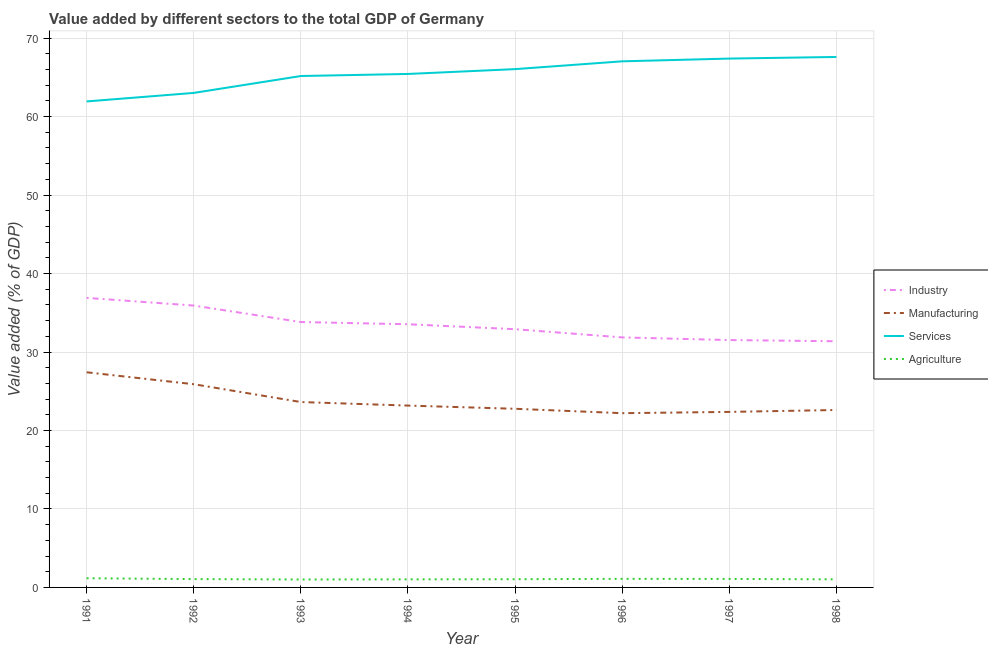Does the line corresponding to value added by manufacturing sector intersect with the line corresponding to value added by agricultural sector?
Ensure brevity in your answer.  No. Is the number of lines equal to the number of legend labels?
Provide a succinct answer. Yes. What is the value added by industrial sector in 1994?
Give a very brief answer. 33.54. Across all years, what is the maximum value added by services sector?
Keep it short and to the point. 67.6. Across all years, what is the minimum value added by industrial sector?
Your response must be concise. 31.37. What is the total value added by manufacturing sector in the graph?
Your response must be concise. 190.06. What is the difference between the value added by agricultural sector in 1994 and that in 1996?
Provide a short and direct response. -0.07. What is the difference between the value added by agricultural sector in 1993 and the value added by manufacturing sector in 1997?
Make the answer very short. -21.36. What is the average value added by manufacturing sector per year?
Make the answer very short. 23.76. In the year 1994, what is the difference between the value added by manufacturing sector and value added by services sector?
Your answer should be very brief. -42.26. What is the ratio of the value added by agricultural sector in 1991 to that in 1996?
Provide a short and direct response. 1.07. Is the value added by agricultural sector in 1992 less than that in 1994?
Your answer should be very brief. No. What is the difference between the highest and the second highest value added by services sector?
Give a very brief answer. 0.21. What is the difference between the highest and the lowest value added by industrial sector?
Your response must be concise. 5.53. In how many years, is the value added by manufacturing sector greater than the average value added by manufacturing sector taken over all years?
Your answer should be very brief. 2. Is the sum of the value added by industrial sector in 1993 and 1996 greater than the maximum value added by agricultural sector across all years?
Your answer should be compact. Yes. Is it the case that in every year, the sum of the value added by manufacturing sector and value added by agricultural sector is greater than the sum of value added by industrial sector and value added by services sector?
Give a very brief answer. Yes. Is it the case that in every year, the sum of the value added by industrial sector and value added by manufacturing sector is greater than the value added by services sector?
Your response must be concise. No. Is the value added by industrial sector strictly greater than the value added by manufacturing sector over the years?
Keep it short and to the point. Yes. How many years are there in the graph?
Keep it short and to the point. 8. What is the difference between two consecutive major ticks on the Y-axis?
Make the answer very short. 10. Are the values on the major ticks of Y-axis written in scientific E-notation?
Offer a very short reply. No. Does the graph contain grids?
Your response must be concise. Yes. How many legend labels are there?
Your response must be concise. 4. What is the title of the graph?
Ensure brevity in your answer.  Value added by different sectors to the total GDP of Germany. What is the label or title of the Y-axis?
Provide a short and direct response. Value added (% of GDP). What is the Value added (% of GDP) of Industry in 1991?
Offer a very short reply. 36.9. What is the Value added (% of GDP) in Manufacturing in 1991?
Your response must be concise. 27.42. What is the Value added (% of GDP) in Services in 1991?
Give a very brief answer. 61.93. What is the Value added (% of GDP) in Agriculture in 1991?
Offer a terse response. 1.17. What is the Value added (% of GDP) in Industry in 1992?
Offer a terse response. 35.92. What is the Value added (% of GDP) of Manufacturing in 1992?
Keep it short and to the point. 25.9. What is the Value added (% of GDP) in Services in 1992?
Provide a succinct answer. 63.02. What is the Value added (% of GDP) in Agriculture in 1992?
Your answer should be compact. 1.06. What is the Value added (% of GDP) of Industry in 1993?
Provide a succinct answer. 33.82. What is the Value added (% of GDP) of Manufacturing in 1993?
Ensure brevity in your answer.  23.63. What is the Value added (% of GDP) of Services in 1993?
Keep it short and to the point. 65.17. What is the Value added (% of GDP) of Agriculture in 1993?
Your answer should be very brief. 1.01. What is the Value added (% of GDP) of Industry in 1994?
Offer a terse response. 33.54. What is the Value added (% of GDP) of Manufacturing in 1994?
Provide a succinct answer. 23.17. What is the Value added (% of GDP) in Services in 1994?
Your response must be concise. 65.43. What is the Value added (% of GDP) of Agriculture in 1994?
Your answer should be compact. 1.03. What is the Value added (% of GDP) in Industry in 1995?
Your answer should be very brief. 32.91. What is the Value added (% of GDP) of Manufacturing in 1995?
Offer a very short reply. 22.77. What is the Value added (% of GDP) of Services in 1995?
Provide a short and direct response. 66.05. What is the Value added (% of GDP) in Agriculture in 1995?
Give a very brief answer. 1.04. What is the Value added (% of GDP) of Industry in 1996?
Give a very brief answer. 31.86. What is the Value added (% of GDP) in Manufacturing in 1996?
Ensure brevity in your answer.  22.21. What is the Value added (% of GDP) of Services in 1996?
Your answer should be very brief. 67.04. What is the Value added (% of GDP) in Agriculture in 1996?
Provide a short and direct response. 1.09. What is the Value added (% of GDP) of Industry in 1997?
Give a very brief answer. 31.52. What is the Value added (% of GDP) of Manufacturing in 1997?
Provide a succinct answer. 22.37. What is the Value added (% of GDP) of Services in 1997?
Keep it short and to the point. 67.39. What is the Value added (% of GDP) in Agriculture in 1997?
Ensure brevity in your answer.  1.08. What is the Value added (% of GDP) in Industry in 1998?
Give a very brief answer. 31.37. What is the Value added (% of GDP) in Manufacturing in 1998?
Give a very brief answer. 22.61. What is the Value added (% of GDP) in Services in 1998?
Offer a terse response. 67.6. What is the Value added (% of GDP) in Agriculture in 1998?
Your answer should be very brief. 1.03. Across all years, what is the maximum Value added (% of GDP) of Industry?
Provide a short and direct response. 36.9. Across all years, what is the maximum Value added (% of GDP) in Manufacturing?
Your answer should be compact. 27.42. Across all years, what is the maximum Value added (% of GDP) in Services?
Keep it short and to the point. 67.6. Across all years, what is the maximum Value added (% of GDP) of Agriculture?
Provide a short and direct response. 1.17. Across all years, what is the minimum Value added (% of GDP) of Industry?
Your answer should be very brief. 31.37. Across all years, what is the minimum Value added (% of GDP) of Manufacturing?
Provide a short and direct response. 22.21. Across all years, what is the minimum Value added (% of GDP) of Services?
Provide a succinct answer. 61.93. Across all years, what is the minimum Value added (% of GDP) in Agriculture?
Your answer should be compact. 1.01. What is the total Value added (% of GDP) in Industry in the graph?
Offer a very short reply. 267.84. What is the total Value added (% of GDP) of Manufacturing in the graph?
Keep it short and to the point. 190.06. What is the total Value added (% of GDP) of Services in the graph?
Provide a short and direct response. 523.64. What is the total Value added (% of GDP) in Agriculture in the graph?
Keep it short and to the point. 8.52. What is the difference between the Value added (% of GDP) in Industry in 1991 and that in 1992?
Provide a short and direct response. 0.98. What is the difference between the Value added (% of GDP) of Manufacturing in 1991 and that in 1992?
Offer a terse response. 1.52. What is the difference between the Value added (% of GDP) in Services in 1991 and that in 1992?
Offer a terse response. -1.09. What is the difference between the Value added (% of GDP) of Agriculture in 1991 and that in 1992?
Provide a succinct answer. 0.11. What is the difference between the Value added (% of GDP) in Industry in 1991 and that in 1993?
Give a very brief answer. 3.08. What is the difference between the Value added (% of GDP) in Manufacturing in 1991 and that in 1993?
Make the answer very short. 3.79. What is the difference between the Value added (% of GDP) of Services in 1991 and that in 1993?
Your answer should be compact. -3.24. What is the difference between the Value added (% of GDP) of Agriculture in 1991 and that in 1993?
Your answer should be compact. 0.16. What is the difference between the Value added (% of GDP) in Industry in 1991 and that in 1994?
Offer a terse response. 3.36. What is the difference between the Value added (% of GDP) of Manufacturing in 1991 and that in 1994?
Offer a terse response. 4.24. What is the difference between the Value added (% of GDP) in Services in 1991 and that in 1994?
Offer a terse response. -3.5. What is the difference between the Value added (% of GDP) in Agriculture in 1991 and that in 1994?
Provide a succinct answer. 0.14. What is the difference between the Value added (% of GDP) in Industry in 1991 and that in 1995?
Provide a succinct answer. 3.99. What is the difference between the Value added (% of GDP) of Manufacturing in 1991 and that in 1995?
Provide a succinct answer. 4.65. What is the difference between the Value added (% of GDP) of Services in 1991 and that in 1995?
Offer a terse response. -4.12. What is the difference between the Value added (% of GDP) of Agriculture in 1991 and that in 1995?
Your response must be concise. 0.12. What is the difference between the Value added (% of GDP) in Industry in 1991 and that in 1996?
Your answer should be very brief. 5.04. What is the difference between the Value added (% of GDP) in Manufacturing in 1991 and that in 1996?
Your answer should be compact. 5.21. What is the difference between the Value added (% of GDP) of Services in 1991 and that in 1996?
Provide a succinct answer. -5.11. What is the difference between the Value added (% of GDP) in Agriculture in 1991 and that in 1996?
Your answer should be compact. 0.07. What is the difference between the Value added (% of GDP) in Industry in 1991 and that in 1997?
Ensure brevity in your answer.  5.38. What is the difference between the Value added (% of GDP) in Manufacturing in 1991 and that in 1997?
Ensure brevity in your answer.  5.05. What is the difference between the Value added (% of GDP) in Services in 1991 and that in 1997?
Give a very brief answer. -5.46. What is the difference between the Value added (% of GDP) of Agriculture in 1991 and that in 1997?
Provide a short and direct response. 0.09. What is the difference between the Value added (% of GDP) in Industry in 1991 and that in 1998?
Offer a terse response. 5.53. What is the difference between the Value added (% of GDP) of Manufacturing in 1991 and that in 1998?
Ensure brevity in your answer.  4.81. What is the difference between the Value added (% of GDP) of Services in 1991 and that in 1998?
Your answer should be very brief. -5.67. What is the difference between the Value added (% of GDP) of Agriculture in 1991 and that in 1998?
Your response must be concise. 0.14. What is the difference between the Value added (% of GDP) of Industry in 1992 and that in 1993?
Make the answer very short. 2.1. What is the difference between the Value added (% of GDP) of Manufacturing in 1992 and that in 1993?
Make the answer very short. 2.27. What is the difference between the Value added (% of GDP) in Services in 1992 and that in 1993?
Offer a very short reply. -2.15. What is the difference between the Value added (% of GDP) of Agriculture in 1992 and that in 1993?
Provide a succinct answer. 0.05. What is the difference between the Value added (% of GDP) in Industry in 1992 and that in 1994?
Offer a terse response. 2.38. What is the difference between the Value added (% of GDP) of Manufacturing in 1992 and that in 1994?
Offer a very short reply. 2.72. What is the difference between the Value added (% of GDP) in Services in 1992 and that in 1994?
Keep it short and to the point. -2.42. What is the difference between the Value added (% of GDP) in Agriculture in 1992 and that in 1994?
Make the answer very short. 0.03. What is the difference between the Value added (% of GDP) of Industry in 1992 and that in 1995?
Give a very brief answer. 3.01. What is the difference between the Value added (% of GDP) of Manufacturing in 1992 and that in 1995?
Your response must be concise. 3.13. What is the difference between the Value added (% of GDP) of Services in 1992 and that in 1995?
Provide a succinct answer. -3.03. What is the difference between the Value added (% of GDP) of Agriculture in 1992 and that in 1995?
Give a very brief answer. 0.02. What is the difference between the Value added (% of GDP) in Industry in 1992 and that in 1996?
Give a very brief answer. 4.06. What is the difference between the Value added (% of GDP) of Manufacturing in 1992 and that in 1996?
Provide a succinct answer. 3.69. What is the difference between the Value added (% of GDP) in Services in 1992 and that in 1996?
Offer a terse response. -4.03. What is the difference between the Value added (% of GDP) of Agriculture in 1992 and that in 1996?
Provide a short and direct response. -0.03. What is the difference between the Value added (% of GDP) in Industry in 1992 and that in 1997?
Your answer should be compact. 4.4. What is the difference between the Value added (% of GDP) of Manufacturing in 1992 and that in 1997?
Your answer should be compact. 3.53. What is the difference between the Value added (% of GDP) in Services in 1992 and that in 1997?
Give a very brief answer. -4.38. What is the difference between the Value added (% of GDP) in Agriculture in 1992 and that in 1997?
Make the answer very short. -0.02. What is the difference between the Value added (% of GDP) of Industry in 1992 and that in 1998?
Provide a succinct answer. 4.55. What is the difference between the Value added (% of GDP) in Manufacturing in 1992 and that in 1998?
Provide a short and direct response. 3.28. What is the difference between the Value added (% of GDP) of Services in 1992 and that in 1998?
Your answer should be very brief. -4.58. What is the difference between the Value added (% of GDP) of Agriculture in 1992 and that in 1998?
Offer a very short reply. 0.03. What is the difference between the Value added (% of GDP) of Industry in 1993 and that in 1994?
Keep it short and to the point. 0.28. What is the difference between the Value added (% of GDP) in Manufacturing in 1993 and that in 1994?
Provide a succinct answer. 0.45. What is the difference between the Value added (% of GDP) in Services in 1993 and that in 1994?
Your response must be concise. -0.26. What is the difference between the Value added (% of GDP) in Agriculture in 1993 and that in 1994?
Make the answer very short. -0.02. What is the difference between the Value added (% of GDP) of Industry in 1993 and that in 1995?
Make the answer very short. 0.91. What is the difference between the Value added (% of GDP) of Manufacturing in 1993 and that in 1995?
Provide a succinct answer. 0.86. What is the difference between the Value added (% of GDP) in Services in 1993 and that in 1995?
Provide a short and direct response. -0.88. What is the difference between the Value added (% of GDP) in Agriculture in 1993 and that in 1995?
Your answer should be very brief. -0.03. What is the difference between the Value added (% of GDP) in Industry in 1993 and that in 1996?
Provide a short and direct response. 1.96. What is the difference between the Value added (% of GDP) of Manufacturing in 1993 and that in 1996?
Give a very brief answer. 1.42. What is the difference between the Value added (% of GDP) in Services in 1993 and that in 1996?
Make the answer very short. -1.87. What is the difference between the Value added (% of GDP) of Agriculture in 1993 and that in 1996?
Keep it short and to the point. -0.08. What is the difference between the Value added (% of GDP) in Industry in 1993 and that in 1997?
Your answer should be compact. 2.3. What is the difference between the Value added (% of GDP) in Manufacturing in 1993 and that in 1997?
Keep it short and to the point. 1.26. What is the difference between the Value added (% of GDP) in Services in 1993 and that in 1997?
Offer a very short reply. -2.22. What is the difference between the Value added (% of GDP) of Agriculture in 1993 and that in 1997?
Offer a terse response. -0.07. What is the difference between the Value added (% of GDP) of Industry in 1993 and that in 1998?
Keep it short and to the point. 2.45. What is the difference between the Value added (% of GDP) of Manufacturing in 1993 and that in 1998?
Ensure brevity in your answer.  1.01. What is the difference between the Value added (% of GDP) of Services in 1993 and that in 1998?
Offer a terse response. -2.43. What is the difference between the Value added (% of GDP) of Agriculture in 1993 and that in 1998?
Make the answer very short. -0.02. What is the difference between the Value added (% of GDP) of Industry in 1994 and that in 1995?
Ensure brevity in your answer.  0.63. What is the difference between the Value added (% of GDP) of Manufacturing in 1994 and that in 1995?
Provide a short and direct response. 0.41. What is the difference between the Value added (% of GDP) of Services in 1994 and that in 1995?
Keep it short and to the point. -0.62. What is the difference between the Value added (% of GDP) of Agriculture in 1994 and that in 1995?
Your answer should be very brief. -0.02. What is the difference between the Value added (% of GDP) of Industry in 1994 and that in 1996?
Your response must be concise. 1.68. What is the difference between the Value added (% of GDP) of Manufacturing in 1994 and that in 1996?
Ensure brevity in your answer.  0.97. What is the difference between the Value added (% of GDP) in Services in 1994 and that in 1996?
Make the answer very short. -1.61. What is the difference between the Value added (% of GDP) in Agriculture in 1994 and that in 1996?
Keep it short and to the point. -0.07. What is the difference between the Value added (% of GDP) in Industry in 1994 and that in 1997?
Keep it short and to the point. 2.02. What is the difference between the Value added (% of GDP) of Manufacturing in 1994 and that in 1997?
Your answer should be compact. 0.81. What is the difference between the Value added (% of GDP) of Services in 1994 and that in 1997?
Offer a terse response. -1.96. What is the difference between the Value added (% of GDP) of Agriculture in 1994 and that in 1997?
Your answer should be compact. -0.06. What is the difference between the Value added (% of GDP) of Industry in 1994 and that in 1998?
Your answer should be very brief. 2.17. What is the difference between the Value added (% of GDP) in Manufacturing in 1994 and that in 1998?
Give a very brief answer. 0.56. What is the difference between the Value added (% of GDP) in Services in 1994 and that in 1998?
Provide a succinct answer. -2.17. What is the difference between the Value added (% of GDP) in Agriculture in 1994 and that in 1998?
Your answer should be very brief. 0. What is the difference between the Value added (% of GDP) in Industry in 1995 and that in 1996?
Your answer should be compact. 1.04. What is the difference between the Value added (% of GDP) of Manufacturing in 1995 and that in 1996?
Offer a very short reply. 0.56. What is the difference between the Value added (% of GDP) of Services in 1995 and that in 1996?
Ensure brevity in your answer.  -0.99. What is the difference between the Value added (% of GDP) of Agriculture in 1995 and that in 1996?
Give a very brief answer. -0.05. What is the difference between the Value added (% of GDP) of Industry in 1995 and that in 1997?
Your answer should be very brief. 1.38. What is the difference between the Value added (% of GDP) of Manufacturing in 1995 and that in 1997?
Your response must be concise. 0.4. What is the difference between the Value added (% of GDP) of Services in 1995 and that in 1997?
Your answer should be compact. -1.35. What is the difference between the Value added (% of GDP) in Agriculture in 1995 and that in 1997?
Give a very brief answer. -0.04. What is the difference between the Value added (% of GDP) of Industry in 1995 and that in 1998?
Your response must be concise. 1.53. What is the difference between the Value added (% of GDP) of Manufacturing in 1995 and that in 1998?
Your response must be concise. 0.15. What is the difference between the Value added (% of GDP) of Services in 1995 and that in 1998?
Ensure brevity in your answer.  -1.55. What is the difference between the Value added (% of GDP) in Agriculture in 1995 and that in 1998?
Provide a succinct answer. 0.02. What is the difference between the Value added (% of GDP) of Industry in 1996 and that in 1997?
Offer a very short reply. 0.34. What is the difference between the Value added (% of GDP) in Manufacturing in 1996 and that in 1997?
Keep it short and to the point. -0.16. What is the difference between the Value added (% of GDP) in Services in 1996 and that in 1997?
Ensure brevity in your answer.  -0.35. What is the difference between the Value added (% of GDP) in Agriculture in 1996 and that in 1997?
Provide a short and direct response. 0.01. What is the difference between the Value added (% of GDP) of Industry in 1996 and that in 1998?
Provide a short and direct response. 0.49. What is the difference between the Value added (% of GDP) in Manufacturing in 1996 and that in 1998?
Offer a very short reply. -0.41. What is the difference between the Value added (% of GDP) of Services in 1996 and that in 1998?
Keep it short and to the point. -0.56. What is the difference between the Value added (% of GDP) in Agriculture in 1996 and that in 1998?
Offer a very short reply. 0.07. What is the difference between the Value added (% of GDP) of Industry in 1997 and that in 1998?
Ensure brevity in your answer.  0.15. What is the difference between the Value added (% of GDP) of Manufacturing in 1997 and that in 1998?
Make the answer very short. -0.24. What is the difference between the Value added (% of GDP) of Services in 1997 and that in 1998?
Your response must be concise. -0.21. What is the difference between the Value added (% of GDP) in Agriculture in 1997 and that in 1998?
Ensure brevity in your answer.  0.06. What is the difference between the Value added (% of GDP) of Industry in 1991 and the Value added (% of GDP) of Manufacturing in 1992?
Your answer should be very brief. 11. What is the difference between the Value added (% of GDP) of Industry in 1991 and the Value added (% of GDP) of Services in 1992?
Your response must be concise. -26.12. What is the difference between the Value added (% of GDP) of Industry in 1991 and the Value added (% of GDP) of Agriculture in 1992?
Ensure brevity in your answer.  35.84. What is the difference between the Value added (% of GDP) of Manufacturing in 1991 and the Value added (% of GDP) of Services in 1992?
Offer a terse response. -35.6. What is the difference between the Value added (% of GDP) of Manufacturing in 1991 and the Value added (% of GDP) of Agriculture in 1992?
Give a very brief answer. 26.36. What is the difference between the Value added (% of GDP) of Services in 1991 and the Value added (% of GDP) of Agriculture in 1992?
Your answer should be compact. 60.87. What is the difference between the Value added (% of GDP) in Industry in 1991 and the Value added (% of GDP) in Manufacturing in 1993?
Offer a very short reply. 13.27. What is the difference between the Value added (% of GDP) in Industry in 1991 and the Value added (% of GDP) in Services in 1993?
Provide a succinct answer. -28.27. What is the difference between the Value added (% of GDP) in Industry in 1991 and the Value added (% of GDP) in Agriculture in 1993?
Keep it short and to the point. 35.89. What is the difference between the Value added (% of GDP) in Manufacturing in 1991 and the Value added (% of GDP) in Services in 1993?
Your response must be concise. -37.75. What is the difference between the Value added (% of GDP) in Manufacturing in 1991 and the Value added (% of GDP) in Agriculture in 1993?
Ensure brevity in your answer.  26.41. What is the difference between the Value added (% of GDP) in Services in 1991 and the Value added (% of GDP) in Agriculture in 1993?
Make the answer very short. 60.92. What is the difference between the Value added (% of GDP) of Industry in 1991 and the Value added (% of GDP) of Manufacturing in 1994?
Provide a short and direct response. 13.73. What is the difference between the Value added (% of GDP) in Industry in 1991 and the Value added (% of GDP) in Services in 1994?
Provide a succinct answer. -28.53. What is the difference between the Value added (% of GDP) of Industry in 1991 and the Value added (% of GDP) of Agriculture in 1994?
Your answer should be compact. 35.87. What is the difference between the Value added (% of GDP) in Manufacturing in 1991 and the Value added (% of GDP) in Services in 1994?
Your response must be concise. -38.02. What is the difference between the Value added (% of GDP) of Manufacturing in 1991 and the Value added (% of GDP) of Agriculture in 1994?
Keep it short and to the point. 26.39. What is the difference between the Value added (% of GDP) in Services in 1991 and the Value added (% of GDP) in Agriculture in 1994?
Provide a short and direct response. 60.9. What is the difference between the Value added (% of GDP) in Industry in 1991 and the Value added (% of GDP) in Manufacturing in 1995?
Give a very brief answer. 14.13. What is the difference between the Value added (% of GDP) of Industry in 1991 and the Value added (% of GDP) of Services in 1995?
Your response must be concise. -29.15. What is the difference between the Value added (% of GDP) in Industry in 1991 and the Value added (% of GDP) in Agriculture in 1995?
Keep it short and to the point. 35.85. What is the difference between the Value added (% of GDP) in Manufacturing in 1991 and the Value added (% of GDP) in Services in 1995?
Make the answer very short. -38.63. What is the difference between the Value added (% of GDP) of Manufacturing in 1991 and the Value added (% of GDP) of Agriculture in 1995?
Your answer should be compact. 26.37. What is the difference between the Value added (% of GDP) in Services in 1991 and the Value added (% of GDP) in Agriculture in 1995?
Keep it short and to the point. 60.89. What is the difference between the Value added (% of GDP) in Industry in 1991 and the Value added (% of GDP) in Manufacturing in 1996?
Provide a short and direct response. 14.69. What is the difference between the Value added (% of GDP) of Industry in 1991 and the Value added (% of GDP) of Services in 1996?
Your response must be concise. -30.14. What is the difference between the Value added (% of GDP) of Industry in 1991 and the Value added (% of GDP) of Agriculture in 1996?
Provide a succinct answer. 35.8. What is the difference between the Value added (% of GDP) of Manufacturing in 1991 and the Value added (% of GDP) of Services in 1996?
Make the answer very short. -39.63. What is the difference between the Value added (% of GDP) of Manufacturing in 1991 and the Value added (% of GDP) of Agriculture in 1996?
Keep it short and to the point. 26.32. What is the difference between the Value added (% of GDP) in Services in 1991 and the Value added (% of GDP) in Agriculture in 1996?
Provide a succinct answer. 60.84. What is the difference between the Value added (% of GDP) of Industry in 1991 and the Value added (% of GDP) of Manufacturing in 1997?
Your answer should be very brief. 14.53. What is the difference between the Value added (% of GDP) in Industry in 1991 and the Value added (% of GDP) in Services in 1997?
Your answer should be very brief. -30.5. What is the difference between the Value added (% of GDP) of Industry in 1991 and the Value added (% of GDP) of Agriculture in 1997?
Offer a very short reply. 35.82. What is the difference between the Value added (% of GDP) in Manufacturing in 1991 and the Value added (% of GDP) in Services in 1997?
Offer a very short reply. -39.98. What is the difference between the Value added (% of GDP) of Manufacturing in 1991 and the Value added (% of GDP) of Agriculture in 1997?
Keep it short and to the point. 26.33. What is the difference between the Value added (% of GDP) of Services in 1991 and the Value added (% of GDP) of Agriculture in 1997?
Ensure brevity in your answer.  60.85. What is the difference between the Value added (% of GDP) in Industry in 1991 and the Value added (% of GDP) in Manufacturing in 1998?
Offer a very short reply. 14.29. What is the difference between the Value added (% of GDP) of Industry in 1991 and the Value added (% of GDP) of Services in 1998?
Ensure brevity in your answer.  -30.7. What is the difference between the Value added (% of GDP) in Industry in 1991 and the Value added (% of GDP) in Agriculture in 1998?
Your response must be concise. 35.87. What is the difference between the Value added (% of GDP) in Manufacturing in 1991 and the Value added (% of GDP) in Services in 1998?
Keep it short and to the point. -40.18. What is the difference between the Value added (% of GDP) in Manufacturing in 1991 and the Value added (% of GDP) in Agriculture in 1998?
Ensure brevity in your answer.  26.39. What is the difference between the Value added (% of GDP) of Services in 1991 and the Value added (% of GDP) of Agriculture in 1998?
Offer a very short reply. 60.9. What is the difference between the Value added (% of GDP) of Industry in 1992 and the Value added (% of GDP) of Manufacturing in 1993?
Your answer should be very brief. 12.29. What is the difference between the Value added (% of GDP) of Industry in 1992 and the Value added (% of GDP) of Services in 1993?
Offer a very short reply. -29.25. What is the difference between the Value added (% of GDP) in Industry in 1992 and the Value added (% of GDP) in Agriculture in 1993?
Your answer should be very brief. 34.91. What is the difference between the Value added (% of GDP) of Manufacturing in 1992 and the Value added (% of GDP) of Services in 1993?
Make the answer very short. -39.27. What is the difference between the Value added (% of GDP) in Manufacturing in 1992 and the Value added (% of GDP) in Agriculture in 1993?
Your response must be concise. 24.89. What is the difference between the Value added (% of GDP) of Services in 1992 and the Value added (% of GDP) of Agriculture in 1993?
Offer a terse response. 62.01. What is the difference between the Value added (% of GDP) in Industry in 1992 and the Value added (% of GDP) in Manufacturing in 1994?
Provide a short and direct response. 12.75. What is the difference between the Value added (% of GDP) of Industry in 1992 and the Value added (% of GDP) of Services in 1994?
Provide a short and direct response. -29.51. What is the difference between the Value added (% of GDP) in Industry in 1992 and the Value added (% of GDP) in Agriculture in 1994?
Your response must be concise. 34.89. What is the difference between the Value added (% of GDP) of Manufacturing in 1992 and the Value added (% of GDP) of Services in 1994?
Offer a very short reply. -39.54. What is the difference between the Value added (% of GDP) in Manufacturing in 1992 and the Value added (% of GDP) in Agriculture in 1994?
Offer a very short reply. 24.87. What is the difference between the Value added (% of GDP) in Services in 1992 and the Value added (% of GDP) in Agriculture in 1994?
Provide a succinct answer. 61.99. What is the difference between the Value added (% of GDP) in Industry in 1992 and the Value added (% of GDP) in Manufacturing in 1995?
Keep it short and to the point. 13.15. What is the difference between the Value added (% of GDP) of Industry in 1992 and the Value added (% of GDP) of Services in 1995?
Offer a very short reply. -30.13. What is the difference between the Value added (% of GDP) in Industry in 1992 and the Value added (% of GDP) in Agriculture in 1995?
Provide a short and direct response. 34.88. What is the difference between the Value added (% of GDP) in Manufacturing in 1992 and the Value added (% of GDP) in Services in 1995?
Offer a terse response. -40.15. What is the difference between the Value added (% of GDP) of Manufacturing in 1992 and the Value added (% of GDP) of Agriculture in 1995?
Provide a succinct answer. 24.85. What is the difference between the Value added (% of GDP) in Services in 1992 and the Value added (% of GDP) in Agriculture in 1995?
Your answer should be compact. 61.97. What is the difference between the Value added (% of GDP) in Industry in 1992 and the Value added (% of GDP) in Manufacturing in 1996?
Your answer should be very brief. 13.71. What is the difference between the Value added (% of GDP) in Industry in 1992 and the Value added (% of GDP) in Services in 1996?
Make the answer very short. -31.12. What is the difference between the Value added (% of GDP) of Industry in 1992 and the Value added (% of GDP) of Agriculture in 1996?
Your response must be concise. 34.83. What is the difference between the Value added (% of GDP) in Manufacturing in 1992 and the Value added (% of GDP) in Services in 1996?
Offer a terse response. -41.15. What is the difference between the Value added (% of GDP) in Manufacturing in 1992 and the Value added (% of GDP) in Agriculture in 1996?
Ensure brevity in your answer.  24.8. What is the difference between the Value added (% of GDP) of Services in 1992 and the Value added (% of GDP) of Agriculture in 1996?
Your answer should be compact. 61.92. What is the difference between the Value added (% of GDP) of Industry in 1992 and the Value added (% of GDP) of Manufacturing in 1997?
Ensure brevity in your answer.  13.55. What is the difference between the Value added (% of GDP) in Industry in 1992 and the Value added (% of GDP) in Services in 1997?
Offer a terse response. -31.47. What is the difference between the Value added (% of GDP) of Industry in 1992 and the Value added (% of GDP) of Agriculture in 1997?
Offer a terse response. 34.84. What is the difference between the Value added (% of GDP) of Manufacturing in 1992 and the Value added (% of GDP) of Services in 1997?
Provide a short and direct response. -41.5. What is the difference between the Value added (% of GDP) of Manufacturing in 1992 and the Value added (% of GDP) of Agriculture in 1997?
Your answer should be very brief. 24.81. What is the difference between the Value added (% of GDP) in Services in 1992 and the Value added (% of GDP) in Agriculture in 1997?
Provide a short and direct response. 61.93. What is the difference between the Value added (% of GDP) in Industry in 1992 and the Value added (% of GDP) in Manufacturing in 1998?
Your response must be concise. 13.31. What is the difference between the Value added (% of GDP) in Industry in 1992 and the Value added (% of GDP) in Services in 1998?
Offer a terse response. -31.68. What is the difference between the Value added (% of GDP) of Industry in 1992 and the Value added (% of GDP) of Agriculture in 1998?
Your response must be concise. 34.89. What is the difference between the Value added (% of GDP) in Manufacturing in 1992 and the Value added (% of GDP) in Services in 1998?
Ensure brevity in your answer.  -41.7. What is the difference between the Value added (% of GDP) of Manufacturing in 1992 and the Value added (% of GDP) of Agriculture in 1998?
Your response must be concise. 24.87. What is the difference between the Value added (% of GDP) in Services in 1992 and the Value added (% of GDP) in Agriculture in 1998?
Provide a succinct answer. 61.99. What is the difference between the Value added (% of GDP) in Industry in 1993 and the Value added (% of GDP) in Manufacturing in 1994?
Make the answer very short. 10.65. What is the difference between the Value added (% of GDP) in Industry in 1993 and the Value added (% of GDP) in Services in 1994?
Provide a succinct answer. -31.61. What is the difference between the Value added (% of GDP) of Industry in 1993 and the Value added (% of GDP) of Agriculture in 1994?
Make the answer very short. 32.79. What is the difference between the Value added (% of GDP) of Manufacturing in 1993 and the Value added (% of GDP) of Services in 1994?
Offer a terse response. -41.81. What is the difference between the Value added (% of GDP) of Manufacturing in 1993 and the Value added (% of GDP) of Agriculture in 1994?
Make the answer very short. 22.6. What is the difference between the Value added (% of GDP) in Services in 1993 and the Value added (% of GDP) in Agriculture in 1994?
Give a very brief answer. 64.14. What is the difference between the Value added (% of GDP) of Industry in 1993 and the Value added (% of GDP) of Manufacturing in 1995?
Provide a succinct answer. 11.05. What is the difference between the Value added (% of GDP) in Industry in 1993 and the Value added (% of GDP) in Services in 1995?
Your response must be concise. -32.23. What is the difference between the Value added (% of GDP) of Industry in 1993 and the Value added (% of GDP) of Agriculture in 1995?
Offer a very short reply. 32.77. What is the difference between the Value added (% of GDP) of Manufacturing in 1993 and the Value added (% of GDP) of Services in 1995?
Ensure brevity in your answer.  -42.42. What is the difference between the Value added (% of GDP) of Manufacturing in 1993 and the Value added (% of GDP) of Agriculture in 1995?
Provide a short and direct response. 22.58. What is the difference between the Value added (% of GDP) in Services in 1993 and the Value added (% of GDP) in Agriculture in 1995?
Your response must be concise. 64.13. What is the difference between the Value added (% of GDP) of Industry in 1993 and the Value added (% of GDP) of Manufacturing in 1996?
Provide a succinct answer. 11.61. What is the difference between the Value added (% of GDP) of Industry in 1993 and the Value added (% of GDP) of Services in 1996?
Provide a short and direct response. -33.22. What is the difference between the Value added (% of GDP) of Industry in 1993 and the Value added (% of GDP) of Agriculture in 1996?
Offer a very short reply. 32.72. What is the difference between the Value added (% of GDP) in Manufacturing in 1993 and the Value added (% of GDP) in Services in 1996?
Give a very brief answer. -43.42. What is the difference between the Value added (% of GDP) of Manufacturing in 1993 and the Value added (% of GDP) of Agriculture in 1996?
Ensure brevity in your answer.  22.53. What is the difference between the Value added (% of GDP) of Services in 1993 and the Value added (% of GDP) of Agriculture in 1996?
Offer a terse response. 64.08. What is the difference between the Value added (% of GDP) in Industry in 1993 and the Value added (% of GDP) in Manufacturing in 1997?
Your answer should be compact. 11.45. What is the difference between the Value added (% of GDP) in Industry in 1993 and the Value added (% of GDP) in Services in 1997?
Make the answer very short. -33.58. What is the difference between the Value added (% of GDP) of Industry in 1993 and the Value added (% of GDP) of Agriculture in 1997?
Give a very brief answer. 32.74. What is the difference between the Value added (% of GDP) in Manufacturing in 1993 and the Value added (% of GDP) in Services in 1997?
Offer a terse response. -43.77. What is the difference between the Value added (% of GDP) of Manufacturing in 1993 and the Value added (% of GDP) of Agriculture in 1997?
Offer a very short reply. 22.54. What is the difference between the Value added (% of GDP) in Services in 1993 and the Value added (% of GDP) in Agriculture in 1997?
Your answer should be very brief. 64.09. What is the difference between the Value added (% of GDP) of Industry in 1993 and the Value added (% of GDP) of Manufacturing in 1998?
Provide a succinct answer. 11.21. What is the difference between the Value added (% of GDP) of Industry in 1993 and the Value added (% of GDP) of Services in 1998?
Give a very brief answer. -33.78. What is the difference between the Value added (% of GDP) in Industry in 1993 and the Value added (% of GDP) in Agriculture in 1998?
Give a very brief answer. 32.79. What is the difference between the Value added (% of GDP) in Manufacturing in 1993 and the Value added (% of GDP) in Services in 1998?
Your answer should be very brief. -43.98. What is the difference between the Value added (% of GDP) of Manufacturing in 1993 and the Value added (% of GDP) of Agriculture in 1998?
Make the answer very short. 22.6. What is the difference between the Value added (% of GDP) of Services in 1993 and the Value added (% of GDP) of Agriculture in 1998?
Make the answer very short. 64.14. What is the difference between the Value added (% of GDP) in Industry in 1994 and the Value added (% of GDP) in Manufacturing in 1995?
Your response must be concise. 10.77. What is the difference between the Value added (% of GDP) of Industry in 1994 and the Value added (% of GDP) of Services in 1995?
Offer a terse response. -32.51. What is the difference between the Value added (% of GDP) of Industry in 1994 and the Value added (% of GDP) of Agriculture in 1995?
Your response must be concise. 32.49. What is the difference between the Value added (% of GDP) in Manufacturing in 1994 and the Value added (% of GDP) in Services in 1995?
Offer a terse response. -42.88. What is the difference between the Value added (% of GDP) in Manufacturing in 1994 and the Value added (% of GDP) in Agriculture in 1995?
Your answer should be very brief. 22.13. What is the difference between the Value added (% of GDP) of Services in 1994 and the Value added (% of GDP) of Agriculture in 1995?
Provide a succinct answer. 64.39. What is the difference between the Value added (% of GDP) in Industry in 1994 and the Value added (% of GDP) in Manufacturing in 1996?
Give a very brief answer. 11.33. What is the difference between the Value added (% of GDP) in Industry in 1994 and the Value added (% of GDP) in Services in 1996?
Provide a short and direct response. -33.5. What is the difference between the Value added (% of GDP) in Industry in 1994 and the Value added (% of GDP) in Agriculture in 1996?
Your answer should be compact. 32.44. What is the difference between the Value added (% of GDP) in Manufacturing in 1994 and the Value added (% of GDP) in Services in 1996?
Provide a short and direct response. -43.87. What is the difference between the Value added (% of GDP) of Manufacturing in 1994 and the Value added (% of GDP) of Agriculture in 1996?
Ensure brevity in your answer.  22.08. What is the difference between the Value added (% of GDP) of Services in 1994 and the Value added (% of GDP) of Agriculture in 1996?
Your answer should be very brief. 64.34. What is the difference between the Value added (% of GDP) of Industry in 1994 and the Value added (% of GDP) of Manufacturing in 1997?
Offer a very short reply. 11.17. What is the difference between the Value added (% of GDP) of Industry in 1994 and the Value added (% of GDP) of Services in 1997?
Your answer should be very brief. -33.86. What is the difference between the Value added (% of GDP) in Industry in 1994 and the Value added (% of GDP) in Agriculture in 1997?
Offer a very short reply. 32.46. What is the difference between the Value added (% of GDP) in Manufacturing in 1994 and the Value added (% of GDP) in Services in 1997?
Provide a succinct answer. -44.22. What is the difference between the Value added (% of GDP) of Manufacturing in 1994 and the Value added (% of GDP) of Agriculture in 1997?
Your answer should be compact. 22.09. What is the difference between the Value added (% of GDP) in Services in 1994 and the Value added (% of GDP) in Agriculture in 1997?
Offer a terse response. 64.35. What is the difference between the Value added (% of GDP) in Industry in 1994 and the Value added (% of GDP) in Manufacturing in 1998?
Your response must be concise. 10.93. What is the difference between the Value added (% of GDP) of Industry in 1994 and the Value added (% of GDP) of Services in 1998?
Provide a short and direct response. -34.06. What is the difference between the Value added (% of GDP) of Industry in 1994 and the Value added (% of GDP) of Agriculture in 1998?
Keep it short and to the point. 32.51. What is the difference between the Value added (% of GDP) of Manufacturing in 1994 and the Value added (% of GDP) of Services in 1998?
Provide a short and direct response. -44.43. What is the difference between the Value added (% of GDP) of Manufacturing in 1994 and the Value added (% of GDP) of Agriculture in 1998?
Keep it short and to the point. 22.15. What is the difference between the Value added (% of GDP) of Services in 1994 and the Value added (% of GDP) of Agriculture in 1998?
Give a very brief answer. 64.41. What is the difference between the Value added (% of GDP) in Industry in 1995 and the Value added (% of GDP) in Manufacturing in 1996?
Ensure brevity in your answer.  10.7. What is the difference between the Value added (% of GDP) in Industry in 1995 and the Value added (% of GDP) in Services in 1996?
Your answer should be compact. -34.14. What is the difference between the Value added (% of GDP) of Industry in 1995 and the Value added (% of GDP) of Agriculture in 1996?
Keep it short and to the point. 31.81. What is the difference between the Value added (% of GDP) in Manufacturing in 1995 and the Value added (% of GDP) in Services in 1996?
Your answer should be very brief. -44.28. What is the difference between the Value added (% of GDP) of Manufacturing in 1995 and the Value added (% of GDP) of Agriculture in 1996?
Your answer should be very brief. 21.67. What is the difference between the Value added (% of GDP) in Services in 1995 and the Value added (% of GDP) in Agriculture in 1996?
Provide a succinct answer. 64.95. What is the difference between the Value added (% of GDP) of Industry in 1995 and the Value added (% of GDP) of Manufacturing in 1997?
Offer a very short reply. 10.54. What is the difference between the Value added (% of GDP) of Industry in 1995 and the Value added (% of GDP) of Services in 1997?
Your answer should be compact. -34.49. What is the difference between the Value added (% of GDP) in Industry in 1995 and the Value added (% of GDP) in Agriculture in 1997?
Keep it short and to the point. 31.82. What is the difference between the Value added (% of GDP) in Manufacturing in 1995 and the Value added (% of GDP) in Services in 1997?
Your answer should be compact. -44.63. What is the difference between the Value added (% of GDP) of Manufacturing in 1995 and the Value added (% of GDP) of Agriculture in 1997?
Provide a succinct answer. 21.68. What is the difference between the Value added (% of GDP) of Services in 1995 and the Value added (% of GDP) of Agriculture in 1997?
Provide a succinct answer. 64.97. What is the difference between the Value added (% of GDP) in Industry in 1995 and the Value added (% of GDP) in Manufacturing in 1998?
Your answer should be compact. 10.3. What is the difference between the Value added (% of GDP) in Industry in 1995 and the Value added (% of GDP) in Services in 1998?
Give a very brief answer. -34.69. What is the difference between the Value added (% of GDP) in Industry in 1995 and the Value added (% of GDP) in Agriculture in 1998?
Keep it short and to the point. 31.88. What is the difference between the Value added (% of GDP) in Manufacturing in 1995 and the Value added (% of GDP) in Services in 1998?
Your response must be concise. -44.84. What is the difference between the Value added (% of GDP) of Manufacturing in 1995 and the Value added (% of GDP) of Agriculture in 1998?
Offer a terse response. 21.74. What is the difference between the Value added (% of GDP) in Services in 1995 and the Value added (% of GDP) in Agriculture in 1998?
Provide a succinct answer. 65.02. What is the difference between the Value added (% of GDP) in Industry in 1996 and the Value added (% of GDP) in Manufacturing in 1997?
Keep it short and to the point. 9.49. What is the difference between the Value added (% of GDP) of Industry in 1996 and the Value added (% of GDP) of Services in 1997?
Provide a succinct answer. -35.53. What is the difference between the Value added (% of GDP) in Industry in 1996 and the Value added (% of GDP) in Agriculture in 1997?
Ensure brevity in your answer.  30.78. What is the difference between the Value added (% of GDP) of Manufacturing in 1996 and the Value added (% of GDP) of Services in 1997?
Offer a terse response. -45.19. What is the difference between the Value added (% of GDP) in Manufacturing in 1996 and the Value added (% of GDP) in Agriculture in 1997?
Your response must be concise. 21.12. What is the difference between the Value added (% of GDP) of Services in 1996 and the Value added (% of GDP) of Agriculture in 1997?
Offer a very short reply. 65.96. What is the difference between the Value added (% of GDP) in Industry in 1996 and the Value added (% of GDP) in Manufacturing in 1998?
Your response must be concise. 9.25. What is the difference between the Value added (% of GDP) in Industry in 1996 and the Value added (% of GDP) in Services in 1998?
Keep it short and to the point. -35.74. What is the difference between the Value added (% of GDP) in Industry in 1996 and the Value added (% of GDP) in Agriculture in 1998?
Provide a short and direct response. 30.83. What is the difference between the Value added (% of GDP) of Manufacturing in 1996 and the Value added (% of GDP) of Services in 1998?
Provide a succinct answer. -45.4. What is the difference between the Value added (% of GDP) in Manufacturing in 1996 and the Value added (% of GDP) in Agriculture in 1998?
Ensure brevity in your answer.  21.18. What is the difference between the Value added (% of GDP) in Services in 1996 and the Value added (% of GDP) in Agriculture in 1998?
Provide a succinct answer. 66.02. What is the difference between the Value added (% of GDP) in Industry in 1997 and the Value added (% of GDP) in Manufacturing in 1998?
Your answer should be compact. 8.91. What is the difference between the Value added (% of GDP) in Industry in 1997 and the Value added (% of GDP) in Services in 1998?
Your answer should be compact. -36.08. What is the difference between the Value added (% of GDP) in Industry in 1997 and the Value added (% of GDP) in Agriculture in 1998?
Make the answer very short. 30.5. What is the difference between the Value added (% of GDP) of Manufacturing in 1997 and the Value added (% of GDP) of Services in 1998?
Ensure brevity in your answer.  -45.23. What is the difference between the Value added (% of GDP) in Manufacturing in 1997 and the Value added (% of GDP) in Agriculture in 1998?
Offer a very short reply. 21.34. What is the difference between the Value added (% of GDP) of Services in 1997 and the Value added (% of GDP) of Agriculture in 1998?
Offer a terse response. 66.37. What is the average Value added (% of GDP) of Industry per year?
Provide a succinct answer. 33.48. What is the average Value added (% of GDP) in Manufacturing per year?
Give a very brief answer. 23.76. What is the average Value added (% of GDP) in Services per year?
Your response must be concise. 65.46. What is the average Value added (% of GDP) of Agriculture per year?
Provide a short and direct response. 1.06. In the year 1991, what is the difference between the Value added (% of GDP) in Industry and Value added (% of GDP) in Manufacturing?
Offer a terse response. 9.48. In the year 1991, what is the difference between the Value added (% of GDP) in Industry and Value added (% of GDP) in Services?
Give a very brief answer. -25.03. In the year 1991, what is the difference between the Value added (% of GDP) in Industry and Value added (% of GDP) in Agriculture?
Make the answer very short. 35.73. In the year 1991, what is the difference between the Value added (% of GDP) in Manufacturing and Value added (% of GDP) in Services?
Your response must be concise. -34.51. In the year 1991, what is the difference between the Value added (% of GDP) in Manufacturing and Value added (% of GDP) in Agriculture?
Offer a very short reply. 26.25. In the year 1991, what is the difference between the Value added (% of GDP) of Services and Value added (% of GDP) of Agriculture?
Your answer should be very brief. 60.76. In the year 1992, what is the difference between the Value added (% of GDP) of Industry and Value added (% of GDP) of Manufacturing?
Offer a very short reply. 10.02. In the year 1992, what is the difference between the Value added (% of GDP) in Industry and Value added (% of GDP) in Services?
Offer a very short reply. -27.1. In the year 1992, what is the difference between the Value added (% of GDP) in Industry and Value added (% of GDP) in Agriculture?
Keep it short and to the point. 34.86. In the year 1992, what is the difference between the Value added (% of GDP) of Manufacturing and Value added (% of GDP) of Services?
Your response must be concise. -37.12. In the year 1992, what is the difference between the Value added (% of GDP) of Manufacturing and Value added (% of GDP) of Agriculture?
Keep it short and to the point. 24.83. In the year 1992, what is the difference between the Value added (% of GDP) of Services and Value added (% of GDP) of Agriculture?
Keep it short and to the point. 61.96. In the year 1993, what is the difference between the Value added (% of GDP) of Industry and Value added (% of GDP) of Manufacturing?
Your response must be concise. 10.19. In the year 1993, what is the difference between the Value added (% of GDP) in Industry and Value added (% of GDP) in Services?
Keep it short and to the point. -31.35. In the year 1993, what is the difference between the Value added (% of GDP) of Industry and Value added (% of GDP) of Agriculture?
Your answer should be very brief. 32.81. In the year 1993, what is the difference between the Value added (% of GDP) in Manufacturing and Value added (% of GDP) in Services?
Offer a very short reply. -41.55. In the year 1993, what is the difference between the Value added (% of GDP) in Manufacturing and Value added (% of GDP) in Agriculture?
Give a very brief answer. 22.62. In the year 1993, what is the difference between the Value added (% of GDP) of Services and Value added (% of GDP) of Agriculture?
Offer a terse response. 64.16. In the year 1994, what is the difference between the Value added (% of GDP) of Industry and Value added (% of GDP) of Manufacturing?
Offer a terse response. 10.37. In the year 1994, what is the difference between the Value added (% of GDP) of Industry and Value added (% of GDP) of Services?
Your answer should be very brief. -31.89. In the year 1994, what is the difference between the Value added (% of GDP) in Industry and Value added (% of GDP) in Agriculture?
Your answer should be very brief. 32.51. In the year 1994, what is the difference between the Value added (% of GDP) in Manufacturing and Value added (% of GDP) in Services?
Your answer should be very brief. -42.26. In the year 1994, what is the difference between the Value added (% of GDP) in Manufacturing and Value added (% of GDP) in Agriculture?
Offer a very short reply. 22.15. In the year 1994, what is the difference between the Value added (% of GDP) of Services and Value added (% of GDP) of Agriculture?
Provide a succinct answer. 64.41. In the year 1995, what is the difference between the Value added (% of GDP) of Industry and Value added (% of GDP) of Manufacturing?
Your answer should be compact. 10.14. In the year 1995, what is the difference between the Value added (% of GDP) in Industry and Value added (% of GDP) in Services?
Ensure brevity in your answer.  -33.14. In the year 1995, what is the difference between the Value added (% of GDP) in Industry and Value added (% of GDP) in Agriculture?
Offer a very short reply. 31.86. In the year 1995, what is the difference between the Value added (% of GDP) of Manufacturing and Value added (% of GDP) of Services?
Ensure brevity in your answer.  -43.28. In the year 1995, what is the difference between the Value added (% of GDP) of Manufacturing and Value added (% of GDP) of Agriculture?
Your answer should be compact. 21.72. In the year 1995, what is the difference between the Value added (% of GDP) of Services and Value added (% of GDP) of Agriculture?
Make the answer very short. 65. In the year 1996, what is the difference between the Value added (% of GDP) of Industry and Value added (% of GDP) of Manufacturing?
Your answer should be very brief. 9.66. In the year 1996, what is the difference between the Value added (% of GDP) of Industry and Value added (% of GDP) of Services?
Provide a short and direct response. -35.18. In the year 1996, what is the difference between the Value added (% of GDP) of Industry and Value added (% of GDP) of Agriculture?
Your answer should be compact. 30.77. In the year 1996, what is the difference between the Value added (% of GDP) of Manufacturing and Value added (% of GDP) of Services?
Offer a terse response. -44.84. In the year 1996, what is the difference between the Value added (% of GDP) of Manufacturing and Value added (% of GDP) of Agriculture?
Ensure brevity in your answer.  21.11. In the year 1996, what is the difference between the Value added (% of GDP) in Services and Value added (% of GDP) in Agriculture?
Your response must be concise. 65.95. In the year 1997, what is the difference between the Value added (% of GDP) in Industry and Value added (% of GDP) in Manufacturing?
Make the answer very short. 9.15. In the year 1997, what is the difference between the Value added (% of GDP) of Industry and Value added (% of GDP) of Services?
Your answer should be compact. -35.87. In the year 1997, what is the difference between the Value added (% of GDP) in Industry and Value added (% of GDP) in Agriculture?
Ensure brevity in your answer.  30.44. In the year 1997, what is the difference between the Value added (% of GDP) in Manufacturing and Value added (% of GDP) in Services?
Keep it short and to the point. -45.03. In the year 1997, what is the difference between the Value added (% of GDP) of Manufacturing and Value added (% of GDP) of Agriculture?
Give a very brief answer. 21.28. In the year 1997, what is the difference between the Value added (% of GDP) in Services and Value added (% of GDP) in Agriculture?
Your response must be concise. 66.31. In the year 1998, what is the difference between the Value added (% of GDP) in Industry and Value added (% of GDP) in Manufacturing?
Ensure brevity in your answer.  8.76. In the year 1998, what is the difference between the Value added (% of GDP) in Industry and Value added (% of GDP) in Services?
Offer a very short reply. -36.23. In the year 1998, what is the difference between the Value added (% of GDP) of Industry and Value added (% of GDP) of Agriculture?
Provide a succinct answer. 30.34. In the year 1998, what is the difference between the Value added (% of GDP) of Manufacturing and Value added (% of GDP) of Services?
Offer a terse response. -44.99. In the year 1998, what is the difference between the Value added (% of GDP) in Manufacturing and Value added (% of GDP) in Agriculture?
Provide a short and direct response. 21.58. In the year 1998, what is the difference between the Value added (% of GDP) of Services and Value added (% of GDP) of Agriculture?
Offer a terse response. 66.57. What is the ratio of the Value added (% of GDP) in Industry in 1991 to that in 1992?
Your answer should be compact. 1.03. What is the ratio of the Value added (% of GDP) of Manufacturing in 1991 to that in 1992?
Make the answer very short. 1.06. What is the ratio of the Value added (% of GDP) in Services in 1991 to that in 1992?
Ensure brevity in your answer.  0.98. What is the ratio of the Value added (% of GDP) of Agriculture in 1991 to that in 1992?
Your answer should be very brief. 1.1. What is the ratio of the Value added (% of GDP) in Industry in 1991 to that in 1993?
Ensure brevity in your answer.  1.09. What is the ratio of the Value added (% of GDP) in Manufacturing in 1991 to that in 1993?
Offer a terse response. 1.16. What is the ratio of the Value added (% of GDP) in Services in 1991 to that in 1993?
Keep it short and to the point. 0.95. What is the ratio of the Value added (% of GDP) in Agriculture in 1991 to that in 1993?
Give a very brief answer. 1.16. What is the ratio of the Value added (% of GDP) of Industry in 1991 to that in 1994?
Offer a very short reply. 1.1. What is the ratio of the Value added (% of GDP) of Manufacturing in 1991 to that in 1994?
Offer a very short reply. 1.18. What is the ratio of the Value added (% of GDP) of Services in 1991 to that in 1994?
Make the answer very short. 0.95. What is the ratio of the Value added (% of GDP) in Agriculture in 1991 to that in 1994?
Keep it short and to the point. 1.14. What is the ratio of the Value added (% of GDP) in Industry in 1991 to that in 1995?
Give a very brief answer. 1.12. What is the ratio of the Value added (% of GDP) in Manufacturing in 1991 to that in 1995?
Offer a terse response. 1.2. What is the ratio of the Value added (% of GDP) in Services in 1991 to that in 1995?
Provide a succinct answer. 0.94. What is the ratio of the Value added (% of GDP) of Agriculture in 1991 to that in 1995?
Keep it short and to the point. 1.12. What is the ratio of the Value added (% of GDP) in Industry in 1991 to that in 1996?
Your answer should be compact. 1.16. What is the ratio of the Value added (% of GDP) of Manufacturing in 1991 to that in 1996?
Give a very brief answer. 1.23. What is the ratio of the Value added (% of GDP) of Services in 1991 to that in 1996?
Provide a short and direct response. 0.92. What is the ratio of the Value added (% of GDP) in Agriculture in 1991 to that in 1996?
Provide a succinct answer. 1.07. What is the ratio of the Value added (% of GDP) in Industry in 1991 to that in 1997?
Give a very brief answer. 1.17. What is the ratio of the Value added (% of GDP) in Manufacturing in 1991 to that in 1997?
Keep it short and to the point. 1.23. What is the ratio of the Value added (% of GDP) in Services in 1991 to that in 1997?
Provide a short and direct response. 0.92. What is the ratio of the Value added (% of GDP) of Agriculture in 1991 to that in 1997?
Your answer should be very brief. 1.08. What is the ratio of the Value added (% of GDP) in Industry in 1991 to that in 1998?
Offer a terse response. 1.18. What is the ratio of the Value added (% of GDP) in Manufacturing in 1991 to that in 1998?
Provide a succinct answer. 1.21. What is the ratio of the Value added (% of GDP) of Services in 1991 to that in 1998?
Keep it short and to the point. 0.92. What is the ratio of the Value added (% of GDP) of Agriculture in 1991 to that in 1998?
Offer a very short reply. 1.14. What is the ratio of the Value added (% of GDP) of Industry in 1992 to that in 1993?
Offer a terse response. 1.06. What is the ratio of the Value added (% of GDP) of Manufacturing in 1992 to that in 1993?
Your response must be concise. 1.1. What is the ratio of the Value added (% of GDP) in Services in 1992 to that in 1993?
Keep it short and to the point. 0.97. What is the ratio of the Value added (% of GDP) of Agriculture in 1992 to that in 1993?
Your response must be concise. 1.05. What is the ratio of the Value added (% of GDP) of Industry in 1992 to that in 1994?
Your answer should be very brief. 1.07. What is the ratio of the Value added (% of GDP) of Manufacturing in 1992 to that in 1994?
Provide a succinct answer. 1.12. What is the ratio of the Value added (% of GDP) in Services in 1992 to that in 1994?
Keep it short and to the point. 0.96. What is the ratio of the Value added (% of GDP) of Agriculture in 1992 to that in 1994?
Your response must be concise. 1.03. What is the ratio of the Value added (% of GDP) in Industry in 1992 to that in 1995?
Give a very brief answer. 1.09. What is the ratio of the Value added (% of GDP) in Manufacturing in 1992 to that in 1995?
Give a very brief answer. 1.14. What is the ratio of the Value added (% of GDP) of Services in 1992 to that in 1995?
Give a very brief answer. 0.95. What is the ratio of the Value added (% of GDP) of Agriculture in 1992 to that in 1995?
Make the answer very short. 1.02. What is the ratio of the Value added (% of GDP) of Industry in 1992 to that in 1996?
Your answer should be very brief. 1.13. What is the ratio of the Value added (% of GDP) in Manufacturing in 1992 to that in 1996?
Your answer should be very brief. 1.17. What is the ratio of the Value added (% of GDP) in Services in 1992 to that in 1996?
Ensure brevity in your answer.  0.94. What is the ratio of the Value added (% of GDP) in Agriculture in 1992 to that in 1996?
Your answer should be compact. 0.97. What is the ratio of the Value added (% of GDP) of Industry in 1992 to that in 1997?
Make the answer very short. 1.14. What is the ratio of the Value added (% of GDP) of Manufacturing in 1992 to that in 1997?
Offer a terse response. 1.16. What is the ratio of the Value added (% of GDP) of Services in 1992 to that in 1997?
Your answer should be very brief. 0.94. What is the ratio of the Value added (% of GDP) in Agriculture in 1992 to that in 1997?
Your answer should be compact. 0.98. What is the ratio of the Value added (% of GDP) of Industry in 1992 to that in 1998?
Your answer should be compact. 1.15. What is the ratio of the Value added (% of GDP) in Manufacturing in 1992 to that in 1998?
Ensure brevity in your answer.  1.15. What is the ratio of the Value added (% of GDP) in Services in 1992 to that in 1998?
Provide a succinct answer. 0.93. What is the ratio of the Value added (% of GDP) of Agriculture in 1992 to that in 1998?
Provide a short and direct response. 1.03. What is the ratio of the Value added (% of GDP) in Industry in 1993 to that in 1994?
Keep it short and to the point. 1.01. What is the ratio of the Value added (% of GDP) of Manufacturing in 1993 to that in 1994?
Provide a short and direct response. 1.02. What is the ratio of the Value added (% of GDP) in Services in 1993 to that in 1994?
Your answer should be compact. 1. What is the ratio of the Value added (% of GDP) of Agriculture in 1993 to that in 1994?
Ensure brevity in your answer.  0.98. What is the ratio of the Value added (% of GDP) of Industry in 1993 to that in 1995?
Offer a terse response. 1.03. What is the ratio of the Value added (% of GDP) in Manufacturing in 1993 to that in 1995?
Your response must be concise. 1.04. What is the ratio of the Value added (% of GDP) of Services in 1993 to that in 1995?
Make the answer very short. 0.99. What is the ratio of the Value added (% of GDP) of Industry in 1993 to that in 1996?
Ensure brevity in your answer.  1.06. What is the ratio of the Value added (% of GDP) in Manufacturing in 1993 to that in 1996?
Your answer should be compact. 1.06. What is the ratio of the Value added (% of GDP) in Services in 1993 to that in 1996?
Offer a terse response. 0.97. What is the ratio of the Value added (% of GDP) of Agriculture in 1993 to that in 1996?
Your answer should be very brief. 0.92. What is the ratio of the Value added (% of GDP) of Industry in 1993 to that in 1997?
Ensure brevity in your answer.  1.07. What is the ratio of the Value added (% of GDP) in Manufacturing in 1993 to that in 1997?
Keep it short and to the point. 1.06. What is the ratio of the Value added (% of GDP) in Services in 1993 to that in 1997?
Your response must be concise. 0.97. What is the ratio of the Value added (% of GDP) in Agriculture in 1993 to that in 1997?
Offer a very short reply. 0.93. What is the ratio of the Value added (% of GDP) of Industry in 1993 to that in 1998?
Provide a short and direct response. 1.08. What is the ratio of the Value added (% of GDP) in Manufacturing in 1993 to that in 1998?
Your response must be concise. 1.04. What is the ratio of the Value added (% of GDP) in Services in 1993 to that in 1998?
Provide a short and direct response. 0.96. What is the ratio of the Value added (% of GDP) in Agriculture in 1993 to that in 1998?
Offer a very short reply. 0.98. What is the ratio of the Value added (% of GDP) of Industry in 1994 to that in 1995?
Provide a short and direct response. 1.02. What is the ratio of the Value added (% of GDP) in Manufacturing in 1994 to that in 1995?
Give a very brief answer. 1.02. What is the ratio of the Value added (% of GDP) in Services in 1994 to that in 1995?
Your answer should be compact. 0.99. What is the ratio of the Value added (% of GDP) of Agriculture in 1994 to that in 1995?
Offer a very short reply. 0.98. What is the ratio of the Value added (% of GDP) of Industry in 1994 to that in 1996?
Ensure brevity in your answer.  1.05. What is the ratio of the Value added (% of GDP) in Manufacturing in 1994 to that in 1996?
Keep it short and to the point. 1.04. What is the ratio of the Value added (% of GDP) of Services in 1994 to that in 1996?
Make the answer very short. 0.98. What is the ratio of the Value added (% of GDP) in Agriculture in 1994 to that in 1996?
Your answer should be compact. 0.94. What is the ratio of the Value added (% of GDP) of Industry in 1994 to that in 1997?
Give a very brief answer. 1.06. What is the ratio of the Value added (% of GDP) in Manufacturing in 1994 to that in 1997?
Your answer should be very brief. 1.04. What is the ratio of the Value added (% of GDP) in Services in 1994 to that in 1997?
Provide a short and direct response. 0.97. What is the ratio of the Value added (% of GDP) of Agriculture in 1994 to that in 1997?
Provide a succinct answer. 0.95. What is the ratio of the Value added (% of GDP) of Industry in 1994 to that in 1998?
Make the answer very short. 1.07. What is the ratio of the Value added (% of GDP) in Manufacturing in 1994 to that in 1998?
Your response must be concise. 1.02. What is the ratio of the Value added (% of GDP) in Services in 1994 to that in 1998?
Offer a terse response. 0.97. What is the ratio of the Value added (% of GDP) in Agriculture in 1994 to that in 1998?
Provide a short and direct response. 1. What is the ratio of the Value added (% of GDP) in Industry in 1995 to that in 1996?
Give a very brief answer. 1.03. What is the ratio of the Value added (% of GDP) in Manufacturing in 1995 to that in 1996?
Your answer should be very brief. 1.03. What is the ratio of the Value added (% of GDP) in Services in 1995 to that in 1996?
Your response must be concise. 0.99. What is the ratio of the Value added (% of GDP) of Agriculture in 1995 to that in 1996?
Make the answer very short. 0.95. What is the ratio of the Value added (% of GDP) of Industry in 1995 to that in 1997?
Ensure brevity in your answer.  1.04. What is the ratio of the Value added (% of GDP) of Manufacturing in 1995 to that in 1997?
Give a very brief answer. 1.02. What is the ratio of the Value added (% of GDP) of Services in 1995 to that in 1997?
Make the answer very short. 0.98. What is the ratio of the Value added (% of GDP) in Agriculture in 1995 to that in 1997?
Give a very brief answer. 0.96. What is the ratio of the Value added (% of GDP) of Industry in 1995 to that in 1998?
Keep it short and to the point. 1.05. What is the ratio of the Value added (% of GDP) in Manufacturing in 1995 to that in 1998?
Your response must be concise. 1.01. What is the ratio of the Value added (% of GDP) in Agriculture in 1995 to that in 1998?
Offer a terse response. 1.02. What is the ratio of the Value added (% of GDP) of Industry in 1996 to that in 1997?
Offer a terse response. 1.01. What is the ratio of the Value added (% of GDP) of Manufacturing in 1996 to that in 1997?
Your answer should be very brief. 0.99. What is the ratio of the Value added (% of GDP) of Services in 1996 to that in 1997?
Provide a short and direct response. 0.99. What is the ratio of the Value added (% of GDP) of Agriculture in 1996 to that in 1997?
Your response must be concise. 1.01. What is the ratio of the Value added (% of GDP) of Industry in 1996 to that in 1998?
Give a very brief answer. 1.02. What is the ratio of the Value added (% of GDP) of Manufacturing in 1996 to that in 1998?
Provide a succinct answer. 0.98. What is the ratio of the Value added (% of GDP) of Services in 1996 to that in 1998?
Provide a short and direct response. 0.99. What is the ratio of the Value added (% of GDP) in Agriculture in 1996 to that in 1998?
Ensure brevity in your answer.  1.07. What is the ratio of the Value added (% of GDP) of Manufacturing in 1997 to that in 1998?
Your answer should be compact. 0.99. What is the ratio of the Value added (% of GDP) in Services in 1997 to that in 1998?
Provide a succinct answer. 1. What is the ratio of the Value added (% of GDP) in Agriculture in 1997 to that in 1998?
Ensure brevity in your answer.  1.05. What is the difference between the highest and the second highest Value added (% of GDP) of Industry?
Your response must be concise. 0.98. What is the difference between the highest and the second highest Value added (% of GDP) in Manufacturing?
Provide a succinct answer. 1.52. What is the difference between the highest and the second highest Value added (% of GDP) in Services?
Your response must be concise. 0.21. What is the difference between the highest and the second highest Value added (% of GDP) of Agriculture?
Offer a very short reply. 0.07. What is the difference between the highest and the lowest Value added (% of GDP) in Industry?
Your response must be concise. 5.53. What is the difference between the highest and the lowest Value added (% of GDP) in Manufacturing?
Offer a terse response. 5.21. What is the difference between the highest and the lowest Value added (% of GDP) in Services?
Your response must be concise. 5.67. What is the difference between the highest and the lowest Value added (% of GDP) of Agriculture?
Provide a succinct answer. 0.16. 